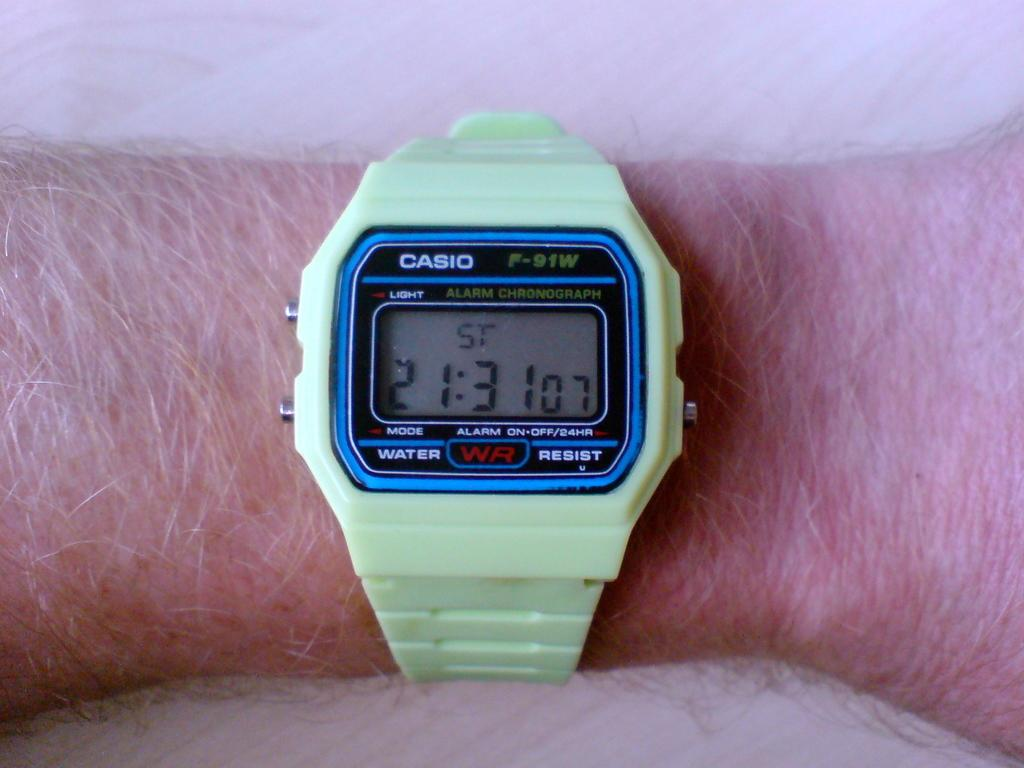<image>
Render a clear and concise summary of the photo. arm with a light green casio digital watch showing time at 21:31 